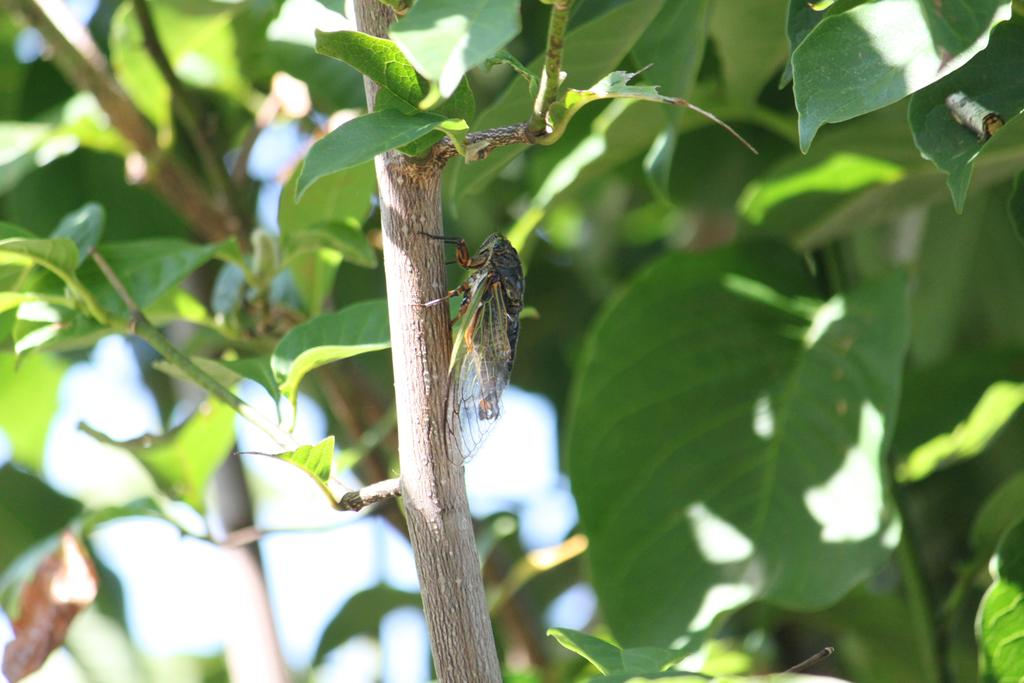What is on the branch of the tree in the image? There is a fly on the branch of a tree in the image. What else can be seen in the image besides the fly? Leaves are visible in the image. What type of wax can be seen melting on the sidewalk near the ocean in the image? There is no wax, sidewalk, or ocean present in the image; it features a fly on a tree branch with leaves. 